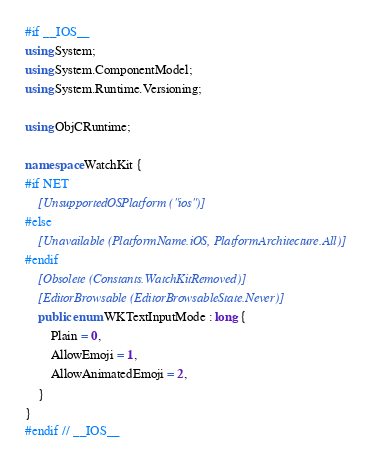<code> <loc_0><loc_0><loc_500><loc_500><_C#_>#if __IOS__
using System;
using System.ComponentModel;
using System.Runtime.Versioning;

using ObjCRuntime;

namespace WatchKit {
#if NET
	[UnsupportedOSPlatform ("ios")]
#else
	[Unavailable (PlatformName.iOS, PlatformArchitecture.All)]
#endif
	[Obsolete (Constants.WatchKitRemoved)]
	[EditorBrowsable (EditorBrowsableState.Never)]
	public enum WKTextInputMode : long {
		Plain = 0,
		AllowEmoji = 1,
		AllowAnimatedEmoji = 2,
	}
}
#endif // __IOS__
</code> 